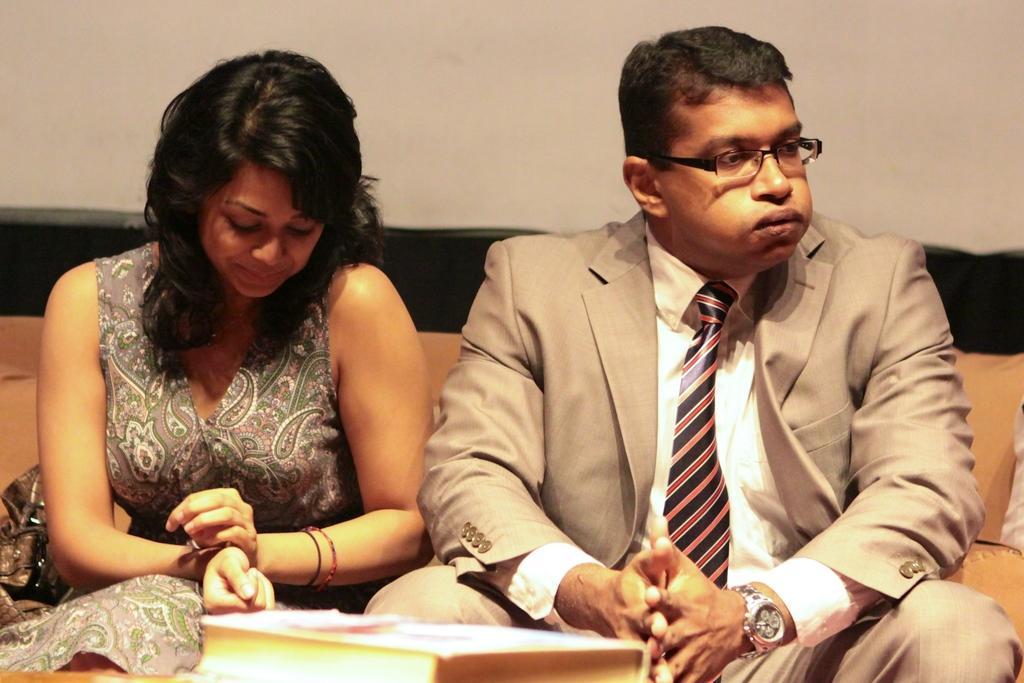Could you give a brief overview of what you see in this image? In this image I can see two persons sitting, the person at right is wearing cream color blazer and cream color shirt, and the person at left is wearing gray color dress. Background the wall is in white color. 